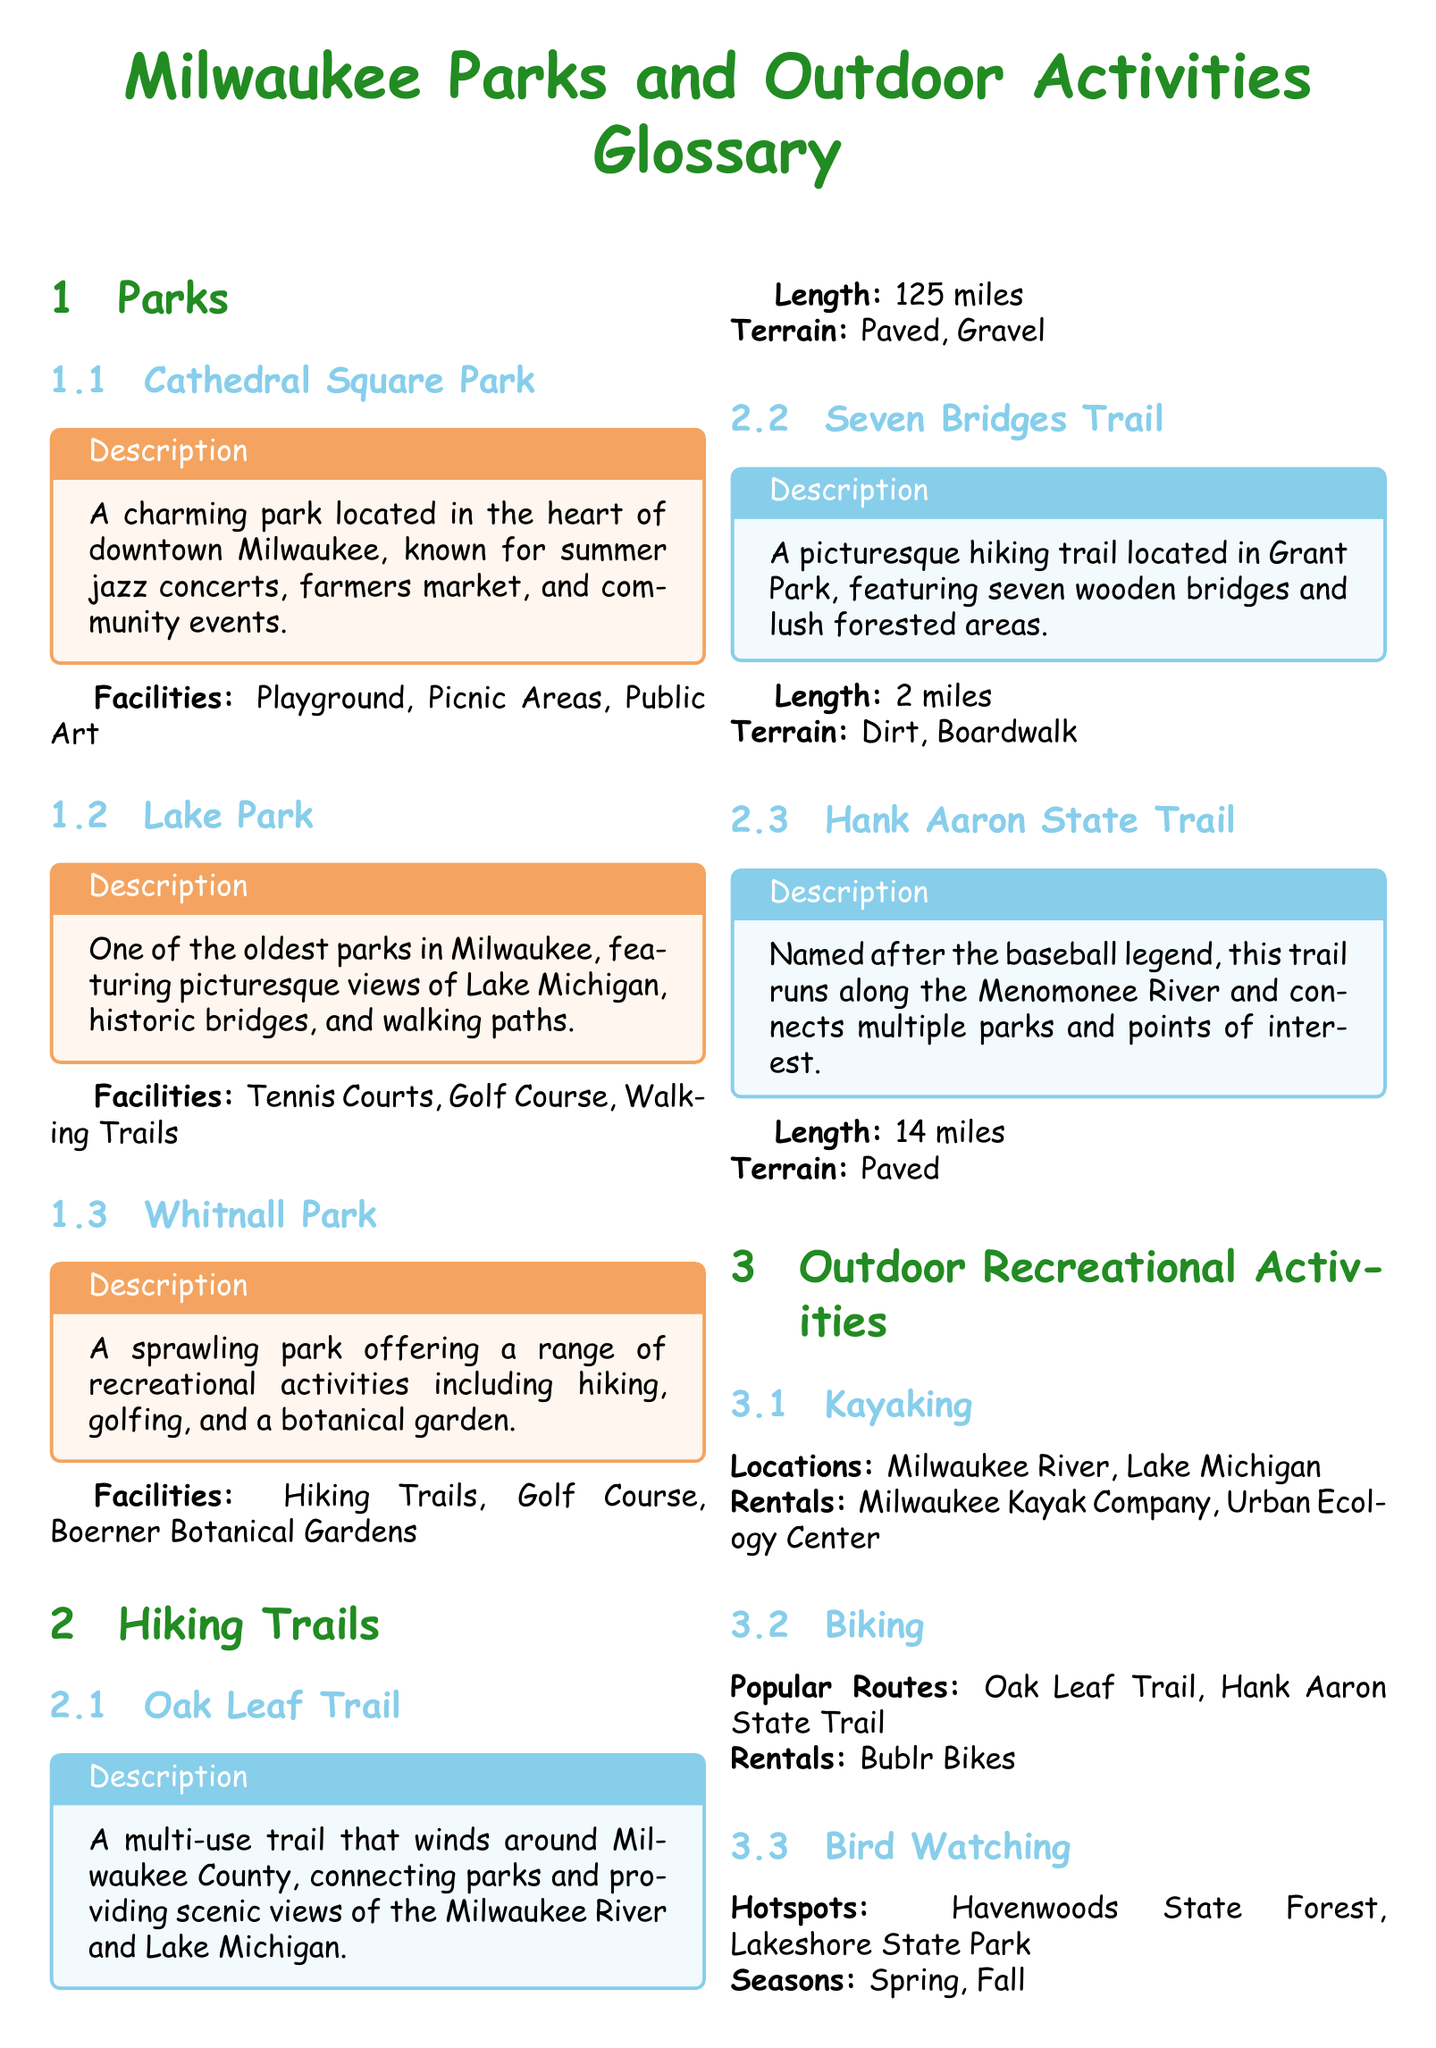What is the length of the Oak Leaf Trail? The document states that the Oak Leaf Trail is 125 miles long.
Answer: 125 miles What type of terrain is the Seven Bridges Trail? The document describes the terrain of the Seven Bridges Trail as Dirt and Boardwalk.
Answer: Dirt, Boardwalk What activities are available at Whitnall Park? The document lists hiking, golfing, and a botanical garden as activities in Whitnall Park.
Answer: Hiking, golfing, botanical garden Where can you rent kayaks in Milwaukee? The document mentions Milwaukee Kayak Company and Urban Ecology Center as kayak rental locations.
Answer: Milwaukee Kayak Company, Urban Ecology Center Which park is known for summer jazz concerts? According to the document, Cathedral Square Park is known for summer jazz concerts.
Answer: Cathedral Square Park What is a popular biking route in Milwaukee? The document identifies Oak Leaf Trail and Hank Aaron State Trail as popular biking routes.
Answer: Oak Leaf Trail What is the total number of parks mentioned in the document? The document lists a total of three parks: Cathedral Square Park, Lake Park, and Whitnall Park.
Answer: 3 What is the main feature of Lake Park? The document highlights picturesque views of Lake Michigan as Lake Park's main feature.
Answer: Picturesque views of Lake Michigan What season is best for bird watching in Milwaukee? The document suggests that spring and fall are the best seasons for bird watching.
Answer: Spring, Fall 